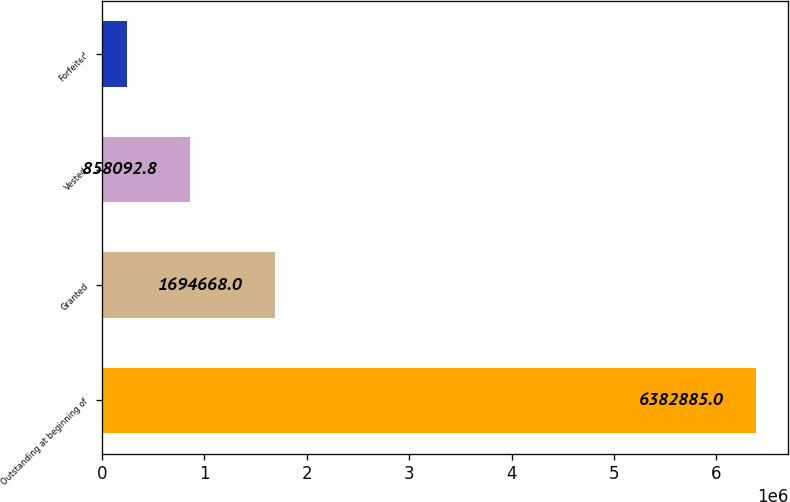<chart> <loc_0><loc_0><loc_500><loc_500><bar_chart><fcel>Outstanding at beginning of<fcel>Granted<fcel>Vested<fcel>Forfeited<nl><fcel>6.38288e+06<fcel>1.69467e+06<fcel>858093<fcel>244227<nl></chart> 